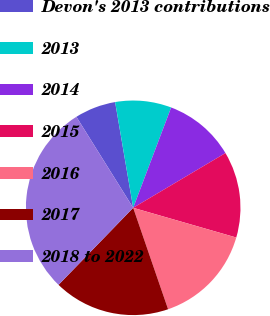Convert chart. <chart><loc_0><loc_0><loc_500><loc_500><pie_chart><fcel>Devon's 2013 contributions<fcel>2013<fcel>2014<fcel>2015<fcel>2016<fcel>2017<fcel>2018 to 2022<nl><fcel>6.19%<fcel>8.45%<fcel>10.72%<fcel>12.99%<fcel>15.26%<fcel>17.53%<fcel>28.87%<nl></chart> 